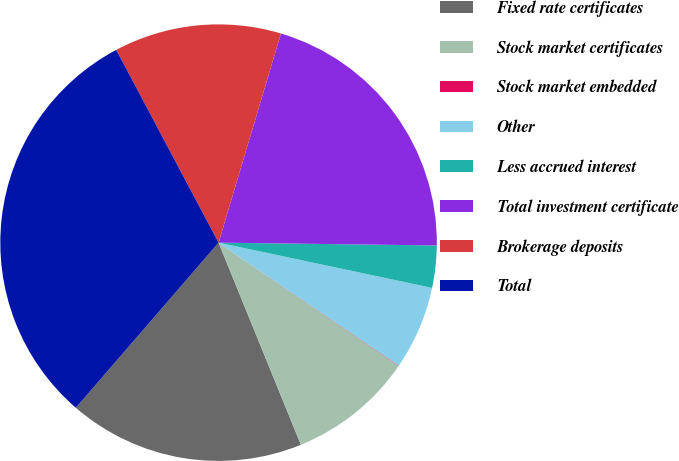Convert chart to OTSL. <chart><loc_0><loc_0><loc_500><loc_500><pie_chart><fcel>Fixed rate certificates<fcel>Stock market certificates<fcel>Stock market embedded<fcel>Other<fcel>Less accrued interest<fcel>Total investment certificate<fcel>Brokerage deposits<fcel>Total<nl><fcel>17.5%<fcel>9.29%<fcel>0.03%<fcel>6.2%<fcel>3.12%<fcel>20.59%<fcel>12.38%<fcel>30.89%<nl></chart> 